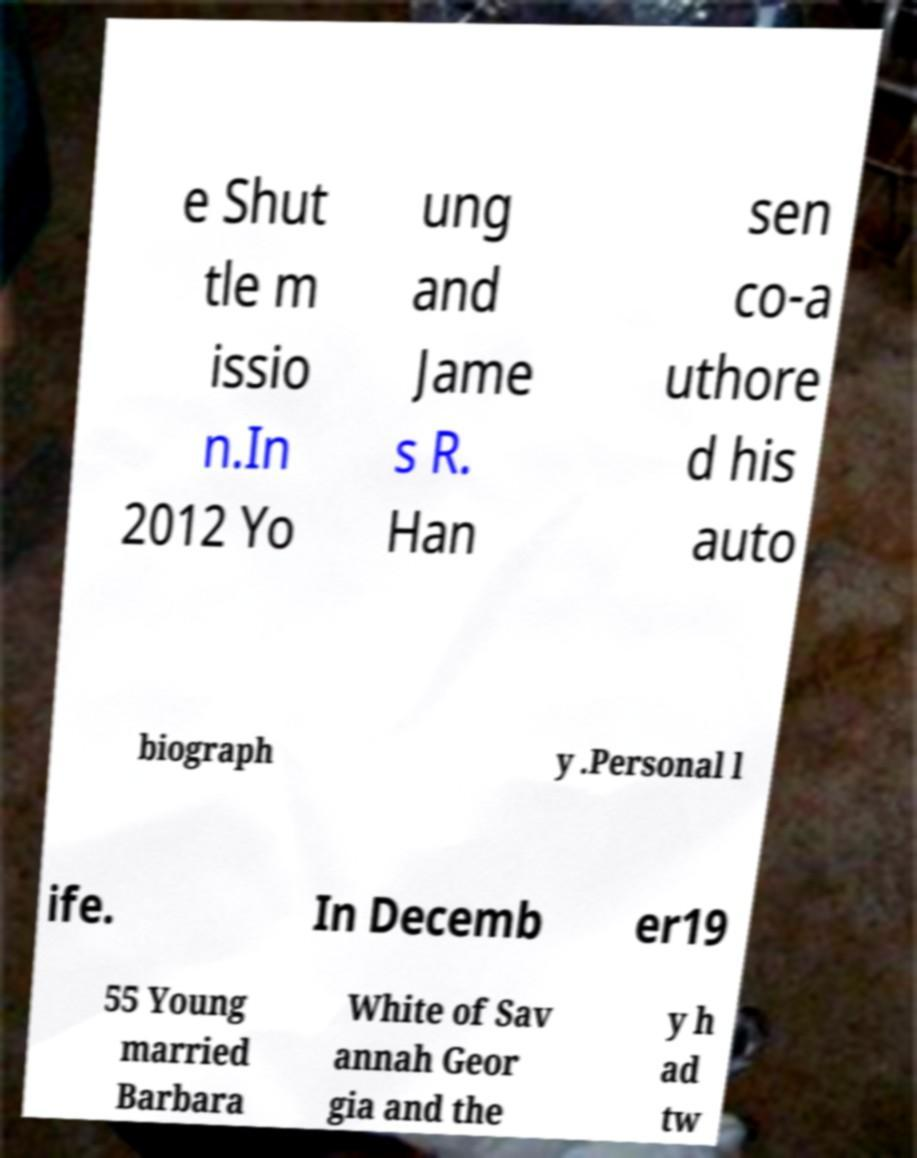I need the written content from this picture converted into text. Can you do that? e Shut tle m issio n.In 2012 Yo ung and Jame s R. Han sen co-a uthore d his auto biograph y .Personal l ife. In Decemb er19 55 Young married Barbara White of Sav annah Geor gia and the y h ad tw 